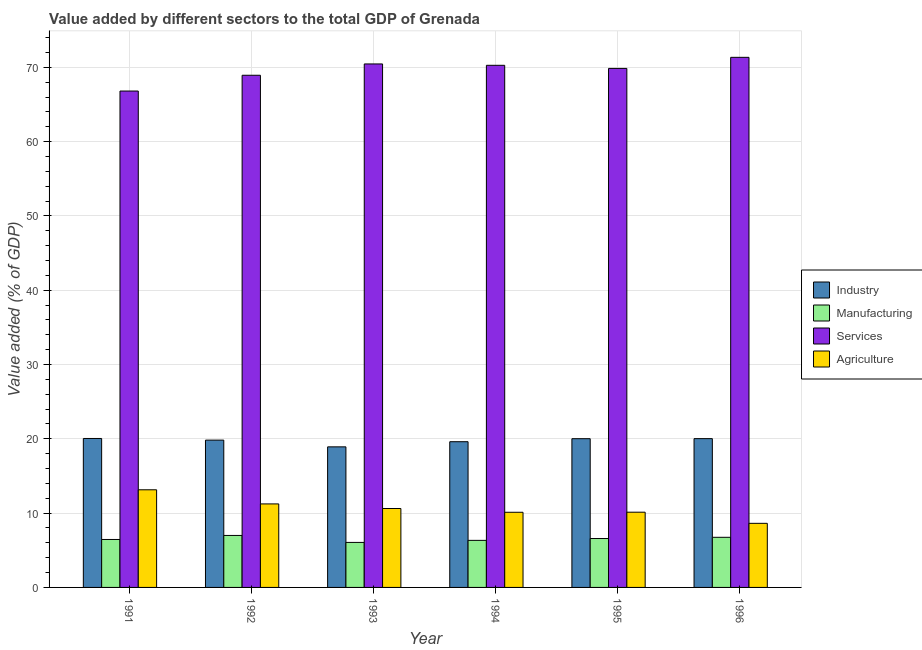Are the number of bars per tick equal to the number of legend labels?
Your response must be concise. Yes. Are the number of bars on each tick of the X-axis equal?
Your answer should be compact. Yes. How many bars are there on the 6th tick from the left?
Provide a succinct answer. 4. How many bars are there on the 6th tick from the right?
Offer a terse response. 4. What is the value added by agricultural sector in 1994?
Provide a succinct answer. 10.11. Across all years, what is the maximum value added by industrial sector?
Your answer should be compact. 20.05. Across all years, what is the minimum value added by industrial sector?
Your response must be concise. 18.92. In which year was the value added by manufacturing sector maximum?
Make the answer very short. 1992. What is the total value added by services sector in the graph?
Keep it short and to the point. 417.68. What is the difference between the value added by agricultural sector in 1992 and that in 1994?
Offer a very short reply. 1.13. What is the difference between the value added by services sector in 1992 and the value added by manufacturing sector in 1995?
Your answer should be compact. -0.92. What is the average value added by industrial sector per year?
Your answer should be compact. 19.74. In the year 1994, what is the difference between the value added by services sector and value added by manufacturing sector?
Your answer should be very brief. 0. What is the ratio of the value added by agricultural sector in 1991 to that in 1992?
Provide a short and direct response. 1.17. Is the value added by manufacturing sector in 1992 less than that in 1996?
Make the answer very short. No. Is the difference between the value added by services sector in 1994 and 1996 greater than the difference between the value added by agricultural sector in 1994 and 1996?
Give a very brief answer. No. What is the difference between the highest and the second highest value added by agricultural sector?
Offer a very short reply. 1.9. What is the difference between the highest and the lowest value added by manufacturing sector?
Provide a short and direct response. 0.94. Is it the case that in every year, the sum of the value added by services sector and value added by manufacturing sector is greater than the sum of value added by industrial sector and value added by agricultural sector?
Provide a succinct answer. No. What does the 1st bar from the left in 1995 represents?
Your answer should be compact. Industry. What does the 4th bar from the right in 1993 represents?
Offer a very short reply. Industry. Are the values on the major ticks of Y-axis written in scientific E-notation?
Give a very brief answer. No. Does the graph contain grids?
Give a very brief answer. Yes. What is the title of the graph?
Your response must be concise. Value added by different sectors to the total GDP of Grenada. Does "Secondary general education" appear as one of the legend labels in the graph?
Offer a terse response. No. What is the label or title of the X-axis?
Your response must be concise. Year. What is the label or title of the Y-axis?
Your answer should be compact. Value added (% of GDP). What is the Value added (% of GDP) of Industry in 1991?
Provide a short and direct response. 20.05. What is the Value added (% of GDP) in Manufacturing in 1991?
Provide a succinct answer. 6.45. What is the Value added (% of GDP) in Services in 1991?
Provide a short and direct response. 66.81. What is the Value added (% of GDP) in Agriculture in 1991?
Give a very brief answer. 13.14. What is the Value added (% of GDP) in Industry in 1992?
Offer a terse response. 19.83. What is the Value added (% of GDP) in Manufacturing in 1992?
Your response must be concise. 7. What is the Value added (% of GDP) in Services in 1992?
Provide a succinct answer. 68.93. What is the Value added (% of GDP) of Agriculture in 1992?
Keep it short and to the point. 11.24. What is the Value added (% of GDP) of Industry in 1993?
Ensure brevity in your answer.  18.92. What is the Value added (% of GDP) of Manufacturing in 1993?
Make the answer very short. 6.06. What is the Value added (% of GDP) in Services in 1993?
Offer a very short reply. 70.46. What is the Value added (% of GDP) in Agriculture in 1993?
Your answer should be compact. 10.62. What is the Value added (% of GDP) in Industry in 1994?
Your answer should be very brief. 19.61. What is the Value added (% of GDP) in Manufacturing in 1994?
Provide a succinct answer. 6.33. What is the Value added (% of GDP) of Services in 1994?
Your answer should be compact. 70.27. What is the Value added (% of GDP) of Agriculture in 1994?
Provide a succinct answer. 10.11. What is the Value added (% of GDP) in Industry in 1995?
Your answer should be very brief. 20.02. What is the Value added (% of GDP) of Manufacturing in 1995?
Offer a terse response. 6.58. What is the Value added (% of GDP) in Services in 1995?
Offer a terse response. 69.86. What is the Value added (% of GDP) of Agriculture in 1995?
Your answer should be compact. 10.13. What is the Value added (% of GDP) of Industry in 1996?
Keep it short and to the point. 20.03. What is the Value added (% of GDP) of Manufacturing in 1996?
Ensure brevity in your answer.  6.75. What is the Value added (% of GDP) in Services in 1996?
Keep it short and to the point. 71.35. What is the Value added (% of GDP) in Agriculture in 1996?
Ensure brevity in your answer.  8.63. Across all years, what is the maximum Value added (% of GDP) of Industry?
Your answer should be compact. 20.05. Across all years, what is the maximum Value added (% of GDP) of Manufacturing?
Offer a very short reply. 7. Across all years, what is the maximum Value added (% of GDP) of Services?
Keep it short and to the point. 71.35. Across all years, what is the maximum Value added (% of GDP) of Agriculture?
Your answer should be compact. 13.14. Across all years, what is the minimum Value added (% of GDP) in Industry?
Make the answer very short. 18.92. Across all years, what is the minimum Value added (% of GDP) in Manufacturing?
Provide a succinct answer. 6.06. Across all years, what is the minimum Value added (% of GDP) of Services?
Provide a succinct answer. 66.81. Across all years, what is the minimum Value added (% of GDP) of Agriculture?
Provide a short and direct response. 8.63. What is the total Value added (% of GDP) of Industry in the graph?
Ensure brevity in your answer.  118.45. What is the total Value added (% of GDP) of Manufacturing in the graph?
Your answer should be very brief. 39.17. What is the total Value added (% of GDP) of Services in the graph?
Give a very brief answer. 417.68. What is the total Value added (% of GDP) in Agriculture in the graph?
Offer a very short reply. 63.87. What is the difference between the Value added (% of GDP) of Industry in 1991 and that in 1992?
Provide a succinct answer. 0.22. What is the difference between the Value added (% of GDP) of Manufacturing in 1991 and that in 1992?
Keep it short and to the point. -0.54. What is the difference between the Value added (% of GDP) in Services in 1991 and that in 1992?
Your answer should be very brief. -2.12. What is the difference between the Value added (% of GDP) of Agriculture in 1991 and that in 1992?
Ensure brevity in your answer.  1.9. What is the difference between the Value added (% of GDP) in Industry in 1991 and that in 1993?
Make the answer very short. 1.13. What is the difference between the Value added (% of GDP) in Manufacturing in 1991 and that in 1993?
Your answer should be compact. 0.39. What is the difference between the Value added (% of GDP) in Services in 1991 and that in 1993?
Your answer should be compact. -3.65. What is the difference between the Value added (% of GDP) in Agriculture in 1991 and that in 1993?
Make the answer very short. 2.52. What is the difference between the Value added (% of GDP) of Industry in 1991 and that in 1994?
Provide a short and direct response. 0.44. What is the difference between the Value added (% of GDP) of Manufacturing in 1991 and that in 1994?
Make the answer very short. 0.12. What is the difference between the Value added (% of GDP) in Services in 1991 and that in 1994?
Offer a very short reply. -3.46. What is the difference between the Value added (% of GDP) in Agriculture in 1991 and that in 1994?
Provide a short and direct response. 3.03. What is the difference between the Value added (% of GDP) of Industry in 1991 and that in 1995?
Provide a succinct answer. 0.03. What is the difference between the Value added (% of GDP) in Manufacturing in 1991 and that in 1995?
Give a very brief answer. -0.13. What is the difference between the Value added (% of GDP) of Services in 1991 and that in 1995?
Give a very brief answer. -3.05. What is the difference between the Value added (% of GDP) of Agriculture in 1991 and that in 1995?
Offer a terse response. 3.02. What is the difference between the Value added (% of GDP) in Industry in 1991 and that in 1996?
Your answer should be compact. 0.02. What is the difference between the Value added (% of GDP) in Manufacturing in 1991 and that in 1996?
Provide a short and direct response. -0.29. What is the difference between the Value added (% of GDP) of Services in 1991 and that in 1996?
Offer a very short reply. -4.54. What is the difference between the Value added (% of GDP) in Agriculture in 1991 and that in 1996?
Make the answer very short. 4.52. What is the difference between the Value added (% of GDP) in Industry in 1992 and that in 1993?
Your answer should be compact. 0.91. What is the difference between the Value added (% of GDP) in Manufacturing in 1992 and that in 1993?
Your response must be concise. 0.94. What is the difference between the Value added (% of GDP) of Services in 1992 and that in 1993?
Offer a terse response. -1.52. What is the difference between the Value added (% of GDP) of Agriculture in 1992 and that in 1993?
Make the answer very short. 0.62. What is the difference between the Value added (% of GDP) in Industry in 1992 and that in 1994?
Your response must be concise. 0.22. What is the difference between the Value added (% of GDP) in Manufacturing in 1992 and that in 1994?
Provide a short and direct response. 0.66. What is the difference between the Value added (% of GDP) of Services in 1992 and that in 1994?
Provide a succinct answer. -1.34. What is the difference between the Value added (% of GDP) of Agriculture in 1992 and that in 1994?
Give a very brief answer. 1.12. What is the difference between the Value added (% of GDP) in Industry in 1992 and that in 1995?
Your answer should be very brief. -0.19. What is the difference between the Value added (% of GDP) of Manufacturing in 1992 and that in 1995?
Provide a succinct answer. 0.41. What is the difference between the Value added (% of GDP) in Services in 1992 and that in 1995?
Offer a very short reply. -0.92. What is the difference between the Value added (% of GDP) of Agriculture in 1992 and that in 1995?
Provide a succinct answer. 1.11. What is the difference between the Value added (% of GDP) in Industry in 1992 and that in 1996?
Keep it short and to the point. -0.2. What is the difference between the Value added (% of GDP) of Manufacturing in 1992 and that in 1996?
Offer a terse response. 0.25. What is the difference between the Value added (% of GDP) of Services in 1992 and that in 1996?
Make the answer very short. -2.41. What is the difference between the Value added (% of GDP) in Agriculture in 1992 and that in 1996?
Offer a very short reply. 2.61. What is the difference between the Value added (% of GDP) in Industry in 1993 and that in 1994?
Provide a short and direct response. -0.69. What is the difference between the Value added (% of GDP) in Manufacturing in 1993 and that in 1994?
Keep it short and to the point. -0.27. What is the difference between the Value added (% of GDP) in Services in 1993 and that in 1994?
Provide a short and direct response. 0.18. What is the difference between the Value added (% of GDP) of Agriculture in 1993 and that in 1994?
Give a very brief answer. 0.51. What is the difference between the Value added (% of GDP) in Industry in 1993 and that in 1995?
Ensure brevity in your answer.  -1.1. What is the difference between the Value added (% of GDP) of Manufacturing in 1993 and that in 1995?
Keep it short and to the point. -0.52. What is the difference between the Value added (% of GDP) in Services in 1993 and that in 1995?
Your answer should be compact. 0.6. What is the difference between the Value added (% of GDP) of Agriculture in 1993 and that in 1995?
Your answer should be very brief. 0.5. What is the difference between the Value added (% of GDP) in Industry in 1993 and that in 1996?
Provide a succinct answer. -1.11. What is the difference between the Value added (% of GDP) in Manufacturing in 1993 and that in 1996?
Your answer should be compact. -0.69. What is the difference between the Value added (% of GDP) in Services in 1993 and that in 1996?
Provide a succinct answer. -0.89. What is the difference between the Value added (% of GDP) in Agriculture in 1993 and that in 1996?
Provide a short and direct response. 2. What is the difference between the Value added (% of GDP) of Industry in 1994 and that in 1995?
Your response must be concise. -0.41. What is the difference between the Value added (% of GDP) in Manufacturing in 1994 and that in 1995?
Your answer should be compact. -0.25. What is the difference between the Value added (% of GDP) in Services in 1994 and that in 1995?
Your response must be concise. 0.42. What is the difference between the Value added (% of GDP) of Agriculture in 1994 and that in 1995?
Give a very brief answer. -0.01. What is the difference between the Value added (% of GDP) of Industry in 1994 and that in 1996?
Ensure brevity in your answer.  -0.42. What is the difference between the Value added (% of GDP) of Manufacturing in 1994 and that in 1996?
Your answer should be very brief. -0.41. What is the difference between the Value added (% of GDP) of Services in 1994 and that in 1996?
Provide a short and direct response. -1.07. What is the difference between the Value added (% of GDP) in Agriculture in 1994 and that in 1996?
Provide a short and direct response. 1.49. What is the difference between the Value added (% of GDP) in Industry in 1995 and that in 1996?
Keep it short and to the point. -0.01. What is the difference between the Value added (% of GDP) in Manufacturing in 1995 and that in 1996?
Provide a succinct answer. -0.16. What is the difference between the Value added (% of GDP) of Services in 1995 and that in 1996?
Your answer should be very brief. -1.49. What is the difference between the Value added (% of GDP) in Agriculture in 1995 and that in 1996?
Offer a very short reply. 1.5. What is the difference between the Value added (% of GDP) in Industry in 1991 and the Value added (% of GDP) in Manufacturing in 1992?
Your answer should be very brief. 13.05. What is the difference between the Value added (% of GDP) in Industry in 1991 and the Value added (% of GDP) in Services in 1992?
Make the answer very short. -48.89. What is the difference between the Value added (% of GDP) in Industry in 1991 and the Value added (% of GDP) in Agriculture in 1992?
Your answer should be compact. 8.81. What is the difference between the Value added (% of GDP) in Manufacturing in 1991 and the Value added (% of GDP) in Services in 1992?
Your response must be concise. -62.48. What is the difference between the Value added (% of GDP) of Manufacturing in 1991 and the Value added (% of GDP) of Agriculture in 1992?
Give a very brief answer. -4.79. What is the difference between the Value added (% of GDP) in Services in 1991 and the Value added (% of GDP) in Agriculture in 1992?
Your response must be concise. 55.57. What is the difference between the Value added (% of GDP) in Industry in 1991 and the Value added (% of GDP) in Manufacturing in 1993?
Ensure brevity in your answer.  13.99. What is the difference between the Value added (% of GDP) in Industry in 1991 and the Value added (% of GDP) in Services in 1993?
Ensure brevity in your answer.  -50.41. What is the difference between the Value added (% of GDP) in Industry in 1991 and the Value added (% of GDP) in Agriculture in 1993?
Offer a terse response. 9.43. What is the difference between the Value added (% of GDP) of Manufacturing in 1991 and the Value added (% of GDP) of Services in 1993?
Keep it short and to the point. -64. What is the difference between the Value added (% of GDP) of Manufacturing in 1991 and the Value added (% of GDP) of Agriculture in 1993?
Your answer should be compact. -4.17. What is the difference between the Value added (% of GDP) of Services in 1991 and the Value added (% of GDP) of Agriculture in 1993?
Your response must be concise. 56.19. What is the difference between the Value added (% of GDP) of Industry in 1991 and the Value added (% of GDP) of Manufacturing in 1994?
Offer a terse response. 13.71. What is the difference between the Value added (% of GDP) of Industry in 1991 and the Value added (% of GDP) of Services in 1994?
Provide a succinct answer. -50.23. What is the difference between the Value added (% of GDP) in Industry in 1991 and the Value added (% of GDP) in Agriculture in 1994?
Keep it short and to the point. 9.93. What is the difference between the Value added (% of GDP) in Manufacturing in 1991 and the Value added (% of GDP) in Services in 1994?
Offer a very short reply. -63.82. What is the difference between the Value added (% of GDP) of Manufacturing in 1991 and the Value added (% of GDP) of Agriculture in 1994?
Your answer should be compact. -3.66. What is the difference between the Value added (% of GDP) of Services in 1991 and the Value added (% of GDP) of Agriculture in 1994?
Keep it short and to the point. 56.7. What is the difference between the Value added (% of GDP) in Industry in 1991 and the Value added (% of GDP) in Manufacturing in 1995?
Keep it short and to the point. 13.47. What is the difference between the Value added (% of GDP) in Industry in 1991 and the Value added (% of GDP) in Services in 1995?
Provide a succinct answer. -49.81. What is the difference between the Value added (% of GDP) in Industry in 1991 and the Value added (% of GDP) in Agriculture in 1995?
Make the answer very short. 9.92. What is the difference between the Value added (% of GDP) of Manufacturing in 1991 and the Value added (% of GDP) of Services in 1995?
Give a very brief answer. -63.4. What is the difference between the Value added (% of GDP) in Manufacturing in 1991 and the Value added (% of GDP) in Agriculture in 1995?
Your response must be concise. -3.67. What is the difference between the Value added (% of GDP) in Services in 1991 and the Value added (% of GDP) in Agriculture in 1995?
Ensure brevity in your answer.  56.69. What is the difference between the Value added (% of GDP) of Industry in 1991 and the Value added (% of GDP) of Manufacturing in 1996?
Offer a terse response. 13.3. What is the difference between the Value added (% of GDP) in Industry in 1991 and the Value added (% of GDP) in Services in 1996?
Make the answer very short. -51.3. What is the difference between the Value added (% of GDP) in Industry in 1991 and the Value added (% of GDP) in Agriculture in 1996?
Offer a terse response. 11.42. What is the difference between the Value added (% of GDP) in Manufacturing in 1991 and the Value added (% of GDP) in Services in 1996?
Offer a terse response. -64.89. What is the difference between the Value added (% of GDP) of Manufacturing in 1991 and the Value added (% of GDP) of Agriculture in 1996?
Provide a short and direct response. -2.17. What is the difference between the Value added (% of GDP) in Services in 1991 and the Value added (% of GDP) in Agriculture in 1996?
Your answer should be very brief. 58.19. What is the difference between the Value added (% of GDP) of Industry in 1992 and the Value added (% of GDP) of Manufacturing in 1993?
Keep it short and to the point. 13.77. What is the difference between the Value added (% of GDP) in Industry in 1992 and the Value added (% of GDP) in Services in 1993?
Make the answer very short. -50.63. What is the difference between the Value added (% of GDP) in Industry in 1992 and the Value added (% of GDP) in Agriculture in 1993?
Your answer should be compact. 9.21. What is the difference between the Value added (% of GDP) of Manufacturing in 1992 and the Value added (% of GDP) of Services in 1993?
Keep it short and to the point. -63.46. What is the difference between the Value added (% of GDP) of Manufacturing in 1992 and the Value added (% of GDP) of Agriculture in 1993?
Your answer should be compact. -3.62. What is the difference between the Value added (% of GDP) in Services in 1992 and the Value added (% of GDP) in Agriculture in 1993?
Keep it short and to the point. 58.31. What is the difference between the Value added (% of GDP) of Industry in 1992 and the Value added (% of GDP) of Manufacturing in 1994?
Offer a terse response. 13.49. What is the difference between the Value added (% of GDP) in Industry in 1992 and the Value added (% of GDP) in Services in 1994?
Your answer should be very brief. -50.45. What is the difference between the Value added (% of GDP) in Industry in 1992 and the Value added (% of GDP) in Agriculture in 1994?
Provide a succinct answer. 9.71. What is the difference between the Value added (% of GDP) of Manufacturing in 1992 and the Value added (% of GDP) of Services in 1994?
Your answer should be very brief. -63.28. What is the difference between the Value added (% of GDP) in Manufacturing in 1992 and the Value added (% of GDP) in Agriculture in 1994?
Give a very brief answer. -3.12. What is the difference between the Value added (% of GDP) in Services in 1992 and the Value added (% of GDP) in Agriculture in 1994?
Provide a short and direct response. 58.82. What is the difference between the Value added (% of GDP) in Industry in 1992 and the Value added (% of GDP) in Manufacturing in 1995?
Provide a succinct answer. 13.24. What is the difference between the Value added (% of GDP) in Industry in 1992 and the Value added (% of GDP) in Services in 1995?
Provide a succinct answer. -50.03. What is the difference between the Value added (% of GDP) in Industry in 1992 and the Value added (% of GDP) in Agriculture in 1995?
Your answer should be very brief. 9.7. What is the difference between the Value added (% of GDP) of Manufacturing in 1992 and the Value added (% of GDP) of Services in 1995?
Provide a succinct answer. -62.86. What is the difference between the Value added (% of GDP) of Manufacturing in 1992 and the Value added (% of GDP) of Agriculture in 1995?
Provide a succinct answer. -3.13. What is the difference between the Value added (% of GDP) of Services in 1992 and the Value added (% of GDP) of Agriculture in 1995?
Give a very brief answer. 58.81. What is the difference between the Value added (% of GDP) of Industry in 1992 and the Value added (% of GDP) of Manufacturing in 1996?
Provide a succinct answer. 13.08. What is the difference between the Value added (% of GDP) in Industry in 1992 and the Value added (% of GDP) in Services in 1996?
Give a very brief answer. -51.52. What is the difference between the Value added (% of GDP) in Industry in 1992 and the Value added (% of GDP) in Agriculture in 1996?
Make the answer very short. 11.2. What is the difference between the Value added (% of GDP) of Manufacturing in 1992 and the Value added (% of GDP) of Services in 1996?
Keep it short and to the point. -64.35. What is the difference between the Value added (% of GDP) in Manufacturing in 1992 and the Value added (% of GDP) in Agriculture in 1996?
Ensure brevity in your answer.  -1.63. What is the difference between the Value added (% of GDP) of Services in 1992 and the Value added (% of GDP) of Agriculture in 1996?
Offer a very short reply. 60.31. What is the difference between the Value added (% of GDP) of Industry in 1993 and the Value added (% of GDP) of Manufacturing in 1994?
Your response must be concise. 12.59. What is the difference between the Value added (% of GDP) of Industry in 1993 and the Value added (% of GDP) of Services in 1994?
Provide a short and direct response. -51.35. What is the difference between the Value added (% of GDP) in Industry in 1993 and the Value added (% of GDP) in Agriculture in 1994?
Make the answer very short. 8.81. What is the difference between the Value added (% of GDP) of Manufacturing in 1993 and the Value added (% of GDP) of Services in 1994?
Make the answer very short. -64.21. What is the difference between the Value added (% of GDP) in Manufacturing in 1993 and the Value added (% of GDP) in Agriculture in 1994?
Your answer should be very brief. -4.05. What is the difference between the Value added (% of GDP) in Services in 1993 and the Value added (% of GDP) in Agriculture in 1994?
Provide a succinct answer. 60.34. What is the difference between the Value added (% of GDP) in Industry in 1993 and the Value added (% of GDP) in Manufacturing in 1995?
Give a very brief answer. 12.34. What is the difference between the Value added (% of GDP) in Industry in 1993 and the Value added (% of GDP) in Services in 1995?
Keep it short and to the point. -50.94. What is the difference between the Value added (% of GDP) of Industry in 1993 and the Value added (% of GDP) of Agriculture in 1995?
Your response must be concise. 8.79. What is the difference between the Value added (% of GDP) of Manufacturing in 1993 and the Value added (% of GDP) of Services in 1995?
Offer a very short reply. -63.8. What is the difference between the Value added (% of GDP) in Manufacturing in 1993 and the Value added (% of GDP) in Agriculture in 1995?
Ensure brevity in your answer.  -4.07. What is the difference between the Value added (% of GDP) of Services in 1993 and the Value added (% of GDP) of Agriculture in 1995?
Provide a succinct answer. 60.33. What is the difference between the Value added (% of GDP) of Industry in 1993 and the Value added (% of GDP) of Manufacturing in 1996?
Your answer should be very brief. 12.17. What is the difference between the Value added (% of GDP) in Industry in 1993 and the Value added (% of GDP) in Services in 1996?
Provide a short and direct response. -52.43. What is the difference between the Value added (% of GDP) in Industry in 1993 and the Value added (% of GDP) in Agriculture in 1996?
Offer a terse response. 10.29. What is the difference between the Value added (% of GDP) of Manufacturing in 1993 and the Value added (% of GDP) of Services in 1996?
Make the answer very short. -65.29. What is the difference between the Value added (% of GDP) of Manufacturing in 1993 and the Value added (% of GDP) of Agriculture in 1996?
Ensure brevity in your answer.  -2.57. What is the difference between the Value added (% of GDP) of Services in 1993 and the Value added (% of GDP) of Agriculture in 1996?
Make the answer very short. 61.83. What is the difference between the Value added (% of GDP) in Industry in 1994 and the Value added (% of GDP) in Manufacturing in 1995?
Ensure brevity in your answer.  13.03. What is the difference between the Value added (% of GDP) in Industry in 1994 and the Value added (% of GDP) in Services in 1995?
Ensure brevity in your answer.  -50.24. What is the difference between the Value added (% of GDP) of Industry in 1994 and the Value added (% of GDP) of Agriculture in 1995?
Make the answer very short. 9.49. What is the difference between the Value added (% of GDP) in Manufacturing in 1994 and the Value added (% of GDP) in Services in 1995?
Offer a terse response. -63.52. What is the difference between the Value added (% of GDP) of Manufacturing in 1994 and the Value added (% of GDP) of Agriculture in 1995?
Your answer should be very brief. -3.79. What is the difference between the Value added (% of GDP) in Services in 1994 and the Value added (% of GDP) in Agriculture in 1995?
Offer a very short reply. 60.15. What is the difference between the Value added (% of GDP) in Industry in 1994 and the Value added (% of GDP) in Manufacturing in 1996?
Offer a terse response. 12.86. What is the difference between the Value added (% of GDP) of Industry in 1994 and the Value added (% of GDP) of Services in 1996?
Give a very brief answer. -51.74. What is the difference between the Value added (% of GDP) of Industry in 1994 and the Value added (% of GDP) of Agriculture in 1996?
Your response must be concise. 10.99. What is the difference between the Value added (% of GDP) in Manufacturing in 1994 and the Value added (% of GDP) in Services in 1996?
Offer a very short reply. -65.01. What is the difference between the Value added (% of GDP) in Manufacturing in 1994 and the Value added (% of GDP) in Agriculture in 1996?
Ensure brevity in your answer.  -2.29. What is the difference between the Value added (% of GDP) in Services in 1994 and the Value added (% of GDP) in Agriculture in 1996?
Provide a succinct answer. 61.65. What is the difference between the Value added (% of GDP) in Industry in 1995 and the Value added (% of GDP) in Manufacturing in 1996?
Make the answer very short. 13.27. What is the difference between the Value added (% of GDP) in Industry in 1995 and the Value added (% of GDP) in Services in 1996?
Offer a very short reply. -51.33. What is the difference between the Value added (% of GDP) in Industry in 1995 and the Value added (% of GDP) in Agriculture in 1996?
Offer a terse response. 11.39. What is the difference between the Value added (% of GDP) in Manufacturing in 1995 and the Value added (% of GDP) in Services in 1996?
Your answer should be very brief. -64.77. What is the difference between the Value added (% of GDP) in Manufacturing in 1995 and the Value added (% of GDP) in Agriculture in 1996?
Ensure brevity in your answer.  -2.04. What is the difference between the Value added (% of GDP) of Services in 1995 and the Value added (% of GDP) of Agriculture in 1996?
Give a very brief answer. 61.23. What is the average Value added (% of GDP) of Industry per year?
Keep it short and to the point. 19.74. What is the average Value added (% of GDP) in Manufacturing per year?
Provide a succinct answer. 6.53. What is the average Value added (% of GDP) of Services per year?
Give a very brief answer. 69.61. What is the average Value added (% of GDP) in Agriculture per year?
Offer a terse response. 10.64. In the year 1991, what is the difference between the Value added (% of GDP) of Industry and Value added (% of GDP) of Manufacturing?
Keep it short and to the point. 13.59. In the year 1991, what is the difference between the Value added (% of GDP) in Industry and Value added (% of GDP) in Services?
Provide a short and direct response. -46.76. In the year 1991, what is the difference between the Value added (% of GDP) of Industry and Value added (% of GDP) of Agriculture?
Offer a very short reply. 6.91. In the year 1991, what is the difference between the Value added (% of GDP) in Manufacturing and Value added (% of GDP) in Services?
Provide a succinct answer. -60.36. In the year 1991, what is the difference between the Value added (% of GDP) in Manufacturing and Value added (% of GDP) in Agriculture?
Give a very brief answer. -6.69. In the year 1991, what is the difference between the Value added (% of GDP) in Services and Value added (% of GDP) in Agriculture?
Provide a short and direct response. 53.67. In the year 1992, what is the difference between the Value added (% of GDP) in Industry and Value added (% of GDP) in Manufacturing?
Offer a terse response. 12.83. In the year 1992, what is the difference between the Value added (% of GDP) in Industry and Value added (% of GDP) in Services?
Your response must be concise. -49.11. In the year 1992, what is the difference between the Value added (% of GDP) of Industry and Value added (% of GDP) of Agriculture?
Make the answer very short. 8.59. In the year 1992, what is the difference between the Value added (% of GDP) in Manufacturing and Value added (% of GDP) in Services?
Make the answer very short. -61.94. In the year 1992, what is the difference between the Value added (% of GDP) of Manufacturing and Value added (% of GDP) of Agriculture?
Your answer should be compact. -4.24. In the year 1992, what is the difference between the Value added (% of GDP) of Services and Value added (% of GDP) of Agriculture?
Ensure brevity in your answer.  57.69. In the year 1993, what is the difference between the Value added (% of GDP) in Industry and Value added (% of GDP) in Manufacturing?
Keep it short and to the point. 12.86. In the year 1993, what is the difference between the Value added (% of GDP) in Industry and Value added (% of GDP) in Services?
Your answer should be compact. -51.54. In the year 1993, what is the difference between the Value added (% of GDP) in Industry and Value added (% of GDP) in Agriculture?
Your response must be concise. 8.3. In the year 1993, what is the difference between the Value added (% of GDP) in Manufacturing and Value added (% of GDP) in Services?
Keep it short and to the point. -64.4. In the year 1993, what is the difference between the Value added (% of GDP) of Manufacturing and Value added (% of GDP) of Agriculture?
Offer a terse response. -4.56. In the year 1993, what is the difference between the Value added (% of GDP) of Services and Value added (% of GDP) of Agriculture?
Give a very brief answer. 59.84. In the year 1994, what is the difference between the Value added (% of GDP) in Industry and Value added (% of GDP) in Manufacturing?
Your answer should be very brief. 13.28. In the year 1994, what is the difference between the Value added (% of GDP) of Industry and Value added (% of GDP) of Services?
Ensure brevity in your answer.  -50.66. In the year 1994, what is the difference between the Value added (% of GDP) of Industry and Value added (% of GDP) of Agriculture?
Offer a terse response. 9.5. In the year 1994, what is the difference between the Value added (% of GDP) in Manufacturing and Value added (% of GDP) in Services?
Ensure brevity in your answer.  -63.94. In the year 1994, what is the difference between the Value added (% of GDP) of Manufacturing and Value added (% of GDP) of Agriculture?
Your answer should be compact. -3.78. In the year 1994, what is the difference between the Value added (% of GDP) of Services and Value added (% of GDP) of Agriculture?
Provide a succinct answer. 60.16. In the year 1995, what is the difference between the Value added (% of GDP) of Industry and Value added (% of GDP) of Manufacturing?
Make the answer very short. 13.44. In the year 1995, what is the difference between the Value added (% of GDP) in Industry and Value added (% of GDP) in Services?
Make the answer very short. -49.84. In the year 1995, what is the difference between the Value added (% of GDP) of Industry and Value added (% of GDP) of Agriculture?
Your answer should be very brief. 9.89. In the year 1995, what is the difference between the Value added (% of GDP) of Manufacturing and Value added (% of GDP) of Services?
Make the answer very short. -63.27. In the year 1995, what is the difference between the Value added (% of GDP) in Manufacturing and Value added (% of GDP) in Agriculture?
Your response must be concise. -3.54. In the year 1995, what is the difference between the Value added (% of GDP) of Services and Value added (% of GDP) of Agriculture?
Your answer should be very brief. 59.73. In the year 1996, what is the difference between the Value added (% of GDP) in Industry and Value added (% of GDP) in Manufacturing?
Provide a short and direct response. 13.28. In the year 1996, what is the difference between the Value added (% of GDP) of Industry and Value added (% of GDP) of Services?
Keep it short and to the point. -51.32. In the year 1996, what is the difference between the Value added (% of GDP) in Industry and Value added (% of GDP) in Agriculture?
Ensure brevity in your answer.  11.4. In the year 1996, what is the difference between the Value added (% of GDP) in Manufacturing and Value added (% of GDP) in Services?
Give a very brief answer. -64.6. In the year 1996, what is the difference between the Value added (% of GDP) in Manufacturing and Value added (% of GDP) in Agriculture?
Give a very brief answer. -1.88. In the year 1996, what is the difference between the Value added (% of GDP) in Services and Value added (% of GDP) in Agriculture?
Your response must be concise. 62.72. What is the ratio of the Value added (% of GDP) in Industry in 1991 to that in 1992?
Keep it short and to the point. 1.01. What is the ratio of the Value added (% of GDP) in Manufacturing in 1991 to that in 1992?
Give a very brief answer. 0.92. What is the ratio of the Value added (% of GDP) of Services in 1991 to that in 1992?
Offer a terse response. 0.97. What is the ratio of the Value added (% of GDP) in Agriculture in 1991 to that in 1992?
Your answer should be very brief. 1.17. What is the ratio of the Value added (% of GDP) in Industry in 1991 to that in 1993?
Offer a very short reply. 1.06. What is the ratio of the Value added (% of GDP) in Manufacturing in 1991 to that in 1993?
Give a very brief answer. 1.07. What is the ratio of the Value added (% of GDP) in Services in 1991 to that in 1993?
Keep it short and to the point. 0.95. What is the ratio of the Value added (% of GDP) of Agriculture in 1991 to that in 1993?
Your response must be concise. 1.24. What is the ratio of the Value added (% of GDP) in Industry in 1991 to that in 1994?
Your answer should be very brief. 1.02. What is the ratio of the Value added (% of GDP) of Services in 1991 to that in 1994?
Your response must be concise. 0.95. What is the ratio of the Value added (% of GDP) of Agriculture in 1991 to that in 1994?
Provide a succinct answer. 1.3. What is the ratio of the Value added (% of GDP) in Manufacturing in 1991 to that in 1995?
Your answer should be compact. 0.98. What is the ratio of the Value added (% of GDP) in Services in 1991 to that in 1995?
Provide a succinct answer. 0.96. What is the ratio of the Value added (% of GDP) in Agriculture in 1991 to that in 1995?
Offer a terse response. 1.3. What is the ratio of the Value added (% of GDP) in Industry in 1991 to that in 1996?
Ensure brevity in your answer.  1. What is the ratio of the Value added (% of GDP) of Manufacturing in 1991 to that in 1996?
Make the answer very short. 0.96. What is the ratio of the Value added (% of GDP) in Services in 1991 to that in 1996?
Make the answer very short. 0.94. What is the ratio of the Value added (% of GDP) of Agriculture in 1991 to that in 1996?
Your answer should be compact. 1.52. What is the ratio of the Value added (% of GDP) in Industry in 1992 to that in 1993?
Provide a short and direct response. 1.05. What is the ratio of the Value added (% of GDP) in Manufacturing in 1992 to that in 1993?
Provide a short and direct response. 1.15. What is the ratio of the Value added (% of GDP) of Services in 1992 to that in 1993?
Keep it short and to the point. 0.98. What is the ratio of the Value added (% of GDP) of Agriculture in 1992 to that in 1993?
Offer a very short reply. 1.06. What is the ratio of the Value added (% of GDP) of Industry in 1992 to that in 1994?
Offer a terse response. 1.01. What is the ratio of the Value added (% of GDP) in Manufacturing in 1992 to that in 1994?
Offer a terse response. 1.1. What is the ratio of the Value added (% of GDP) of Services in 1992 to that in 1994?
Provide a short and direct response. 0.98. What is the ratio of the Value added (% of GDP) in Agriculture in 1992 to that in 1994?
Your answer should be compact. 1.11. What is the ratio of the Value added (% of GDP) in Manufacturing in 1992 to that in 1995?
Offer a very short reply. 1.06. What is the ratio of the Value added (% of GDP) in Services in 1992 to that in 1995?
Your answer should be very brief. 0.99. What is the ratio of the Value added (% of GDP) in Agriculture in 1992 to that in 1995?
Make the answer very short. 1.11. What is the ratio of the Value added (% of GDP) in Services in 1992 to that in 1996?
Offer a terse response. 0.97. What is the ratio of the Value added (% of GDP) in Agriculture in 1992 to that in 1996?
Your answer should be very brief. 1.3. What is the ratio of the Value added (% of GDP) of Industry in 1993 to that in 1994?
Offer a very short reply. 0.96. What is the ratio of the Value added (% of GDP) of Manufacturing in 1993 to that in 1994?
Your answer should be compact. 0.96. What is the ratio of the Value added (% of GDP) in Services in 1993 to that in 1994?
Your response must be concise. 1. What is the ratio of the Value added (% of GDP) in Agriculture in 1993 to that in 1994?
Make the answer very short. 1.05. What is the ratio of the Value added (% of GDP) of Industry in 1993 to that in 1995?
Your answer should be compact. 0.95. What is the ratio of the Value added (% of GDP) of Manufacturing in 1993 to that in 1995?
Your answer should be very brief. 0.92. What is the ratio of the Value added (% of GDP) of Services in 1993 to that in 1995?
Give a very brief answer. 1.01. What is the ratio of the Value added (% of GDP) in Agriculture in 1993 to that in 1995?
Offer a very short reply. 1.05. What is the ratio of the Value added (% of GDP) in Industry in 1993 to that in 1996?
Your answer should be very brief. 0.94. What is the ratio of the Value added (% of GDP) in Manufacturing in 1993 to that in 1996?
Offer a terse response. 0.9. What is the ratio of the Value added (% of GDP) of Services in 1993 to that in 1996?
Offer a terse response. 0.99. What is the ratio of the Value added (% of GDP) of Agriculture in 1993 to that in 1996?
Your answer should be very brief. 1.23. What is the ratio of the Value added (% of GDP) in Industry in 1994 to that in 1995?
Offer a terse response. 0.98. What is the ratio of the Value added (% of GDP) of Manufacturing in 1994 to that in 1995?
Your answer should be compact. 0.96. What is the ratio of the Value added (% of GDP) in Agriculture in 1994 to that in 1995?
Your response must be concise. 1. What is the ratio of the Value added (% of GDP) in Industry in 1994 to that in 1996?
Provide a succinct answer. 0.98. What is the ratio of the Value added (% of GDP) of Manufacturing in 1994 to that in 1996?
Your response must be concise. 0.94. What is the ratio of the Value added (% of GDP) of Agriculture in 1994 to that in 1996?
Your response must be concise. 1.17. What is the ratio of the Value added (% of GDP) of Manufacturing in 1995 to that in 1996?
Offer a terse response. 0.98. What is the ratio of the Value added (% of GDP) in Services in 1995 to that in 1996?
Offer a very short reply. 0.98. What is the ratio of the Value added (% of GDP) in Agriculture in 1995 to that in 1996?
Make the answer very short. 1.17. What is the difference between the highest and the second highest Value added (% of GDP) in Industry?
Ensure brevity in your answer.  0.02. What is the difference between the highest and the second highest Value added (% of GDP) in Manufacturing?
Ensure brevity in your answer.  0.25. What is the difference between the highest and the second highest Value added (% of GDP) in Services?
Your answer should be very brief. 0.89. What is the difference between the highest and the second highest Value added (% of GDP) in Agriculture?
Offer a very short reply. 1.9. What is the difference between the highest and the lowest Value added (% of GDP) of Industry?
Your answer should be very brief. 1.13. What is the difference between the highest and the lowest Value added (% of GDP) in Manufacturing?
Provide a short and direct response. 0.94. What is the difference between the highest and the lowest Value added (% of GDP) in Services?
Make the answer very short. 4.54. What is the difference between the highest and the lowest Value added (% of GDP) in Agriculture?
Make the answer very short. 4.52. 